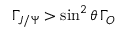Convert formula to latex. <formula><loc_0><loc_0><loc_500><loc_500>\Gamma _ { J / \Psi } > \sin ^ { 2 } \theta \, \Gamma _ { O }</formula> 